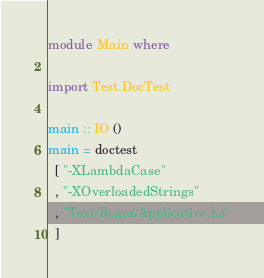<code> <loc_0><loc_0><loc_500><loc_500><_Haskell_>module Main where

import Test.DocTest

main :: IO ()
main = doctest
  [ "-XLambdaCase"
  , "-XOverloadedStrings"
  , "Text/Regex/Applicative.hs"
  ]
</code> 